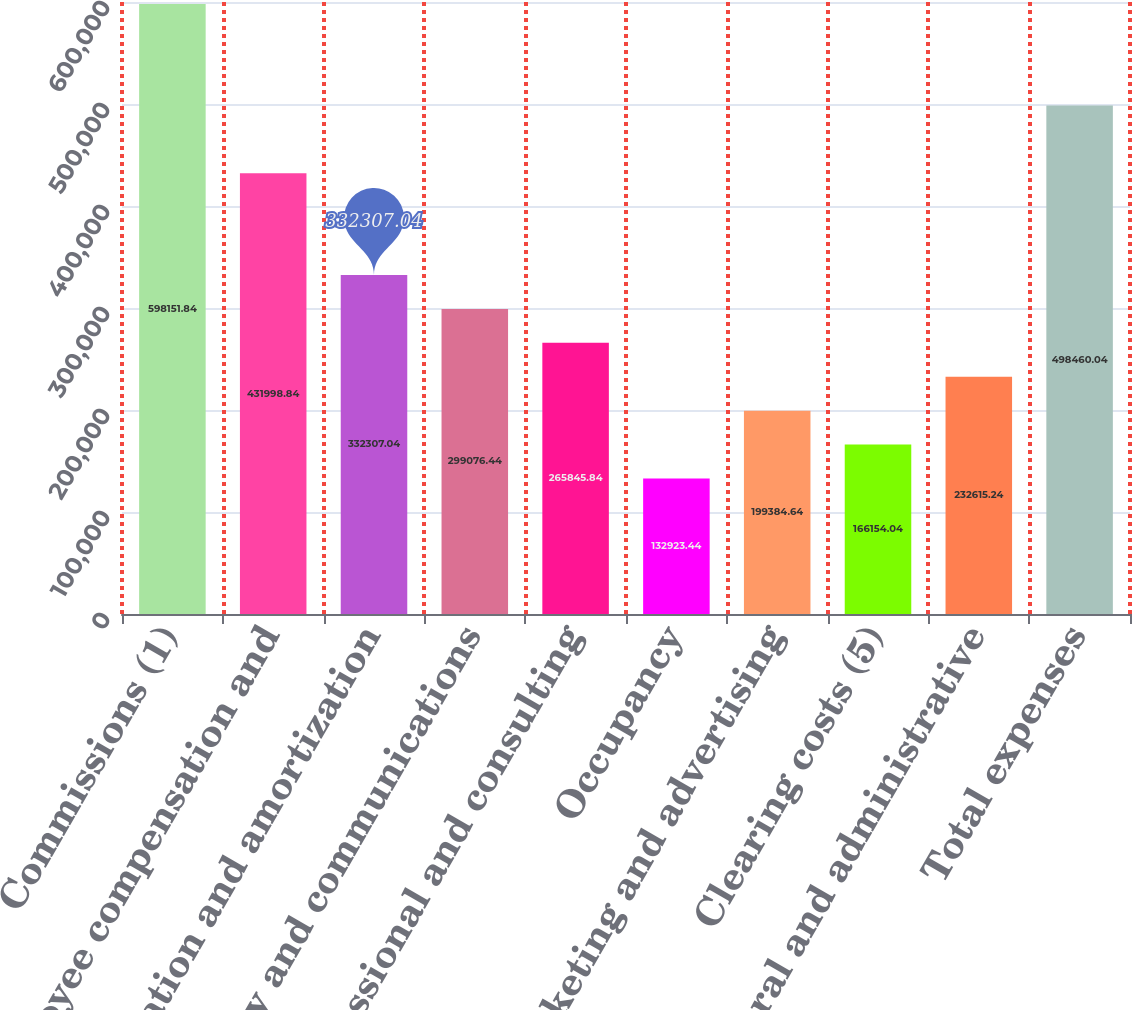Convert chart. <chart><loc_0><loc_0><loc_500><loc_500><bar_chart><fcel>Commissions (1)<fcel>Employee compensation and<fcel>Depreciation and amortization<fcel>Technology and communications<fcel>Professional and consulting<fcel>Occupancy<fcel>Marketing and advertising<fcel>Clearing costs (5)<fcel>General and administrative<fcel>Total expenses<nl><fcel>598152<fcel>431999<fcel>332307<fcel>299076<fcel>265846<fcel>132923<fcel>199385<fcel>166154<fcel>232615<fcel>498460<nl></chart> 